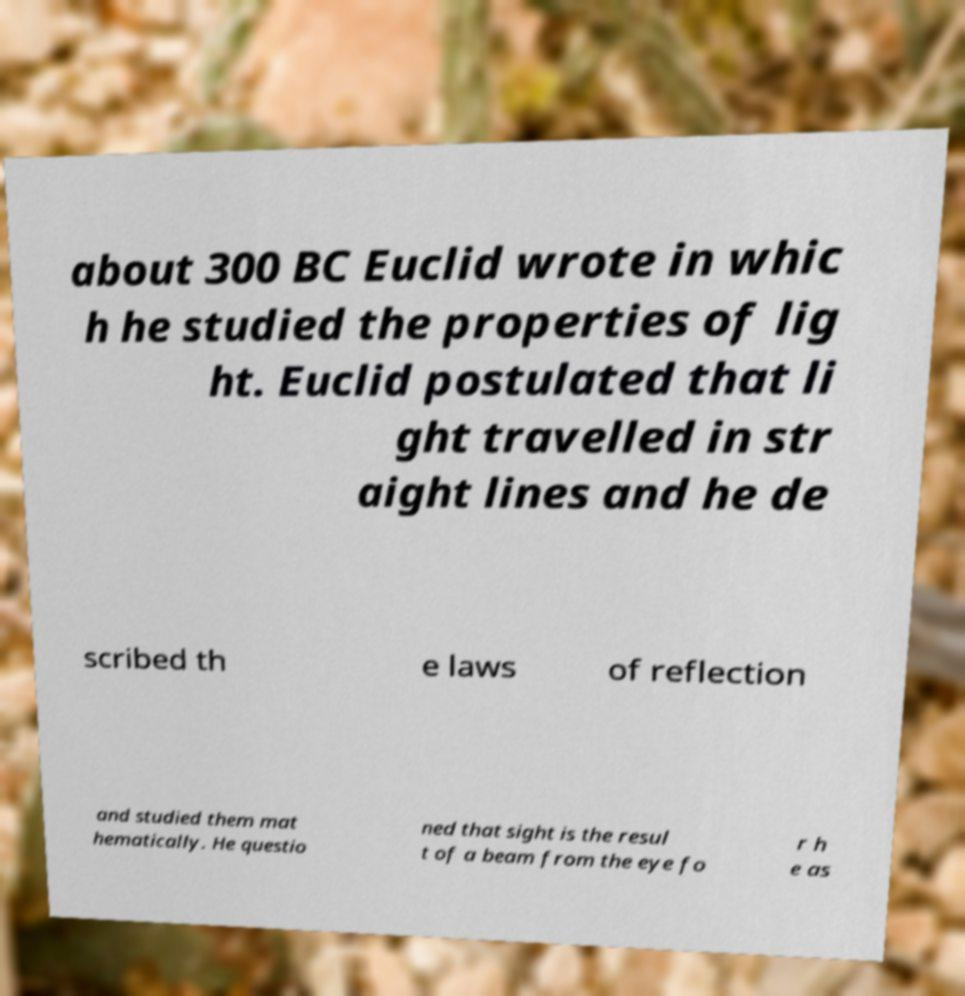Could you extract and type out the text from this image? about 300 BC Euclid wrote in whic h he studied the properties of lig ht. Euclid postulated that li ght travelled in str aight lines and he de scribed th e laws of reflection and studied them mat hematically. He questio ned that sight is the resul t of a beam from the eye fo r h e as 